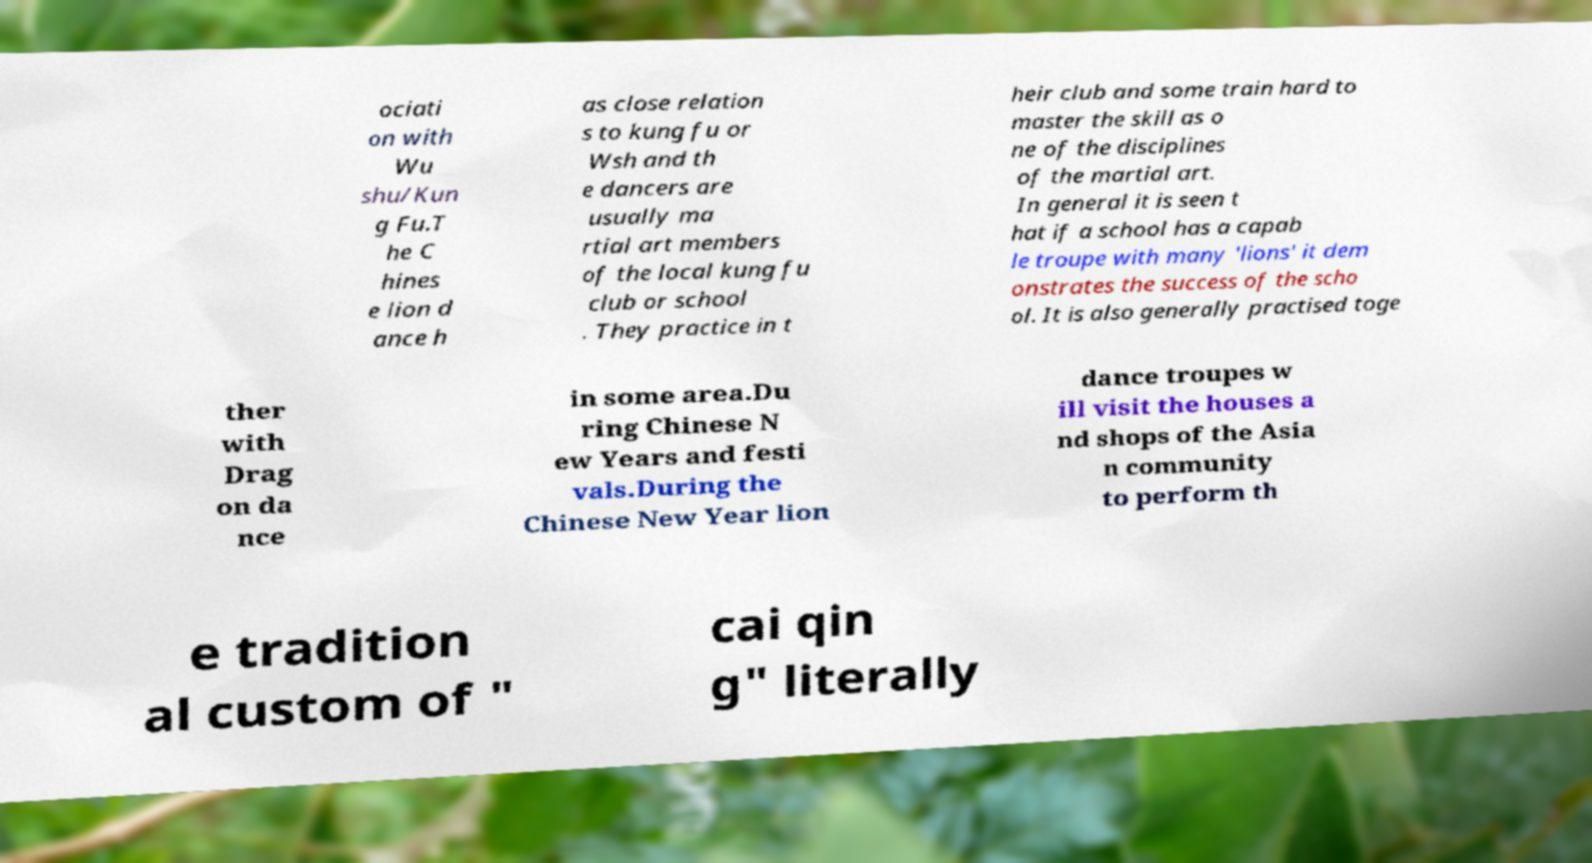Can you accurately transcribe the text from the provided image for me? ociati on with Wu shu/Kun g Fu.T he C hines e lion d ance h as close relation s to kung fu or Wsh and th e dancers are usually ma rtial art members of the local kung fu club or school . They practice in t heir club and some train hard to master the skill as o ne of the disciplines of the martial art. In general it is seen t hat if a school has a capab le troupe with many 'lions' it dem onstrates the success of the scho ol. It is also generally practised toge ther with Drag on da nce in some area.Du ring Chinese N ew Years and festi vals.During the Chinese New Year lion dance troupes w ill visit the houses a nd shops of the Asia n community to perform th e tradition al custom of " cai qin g" literally 